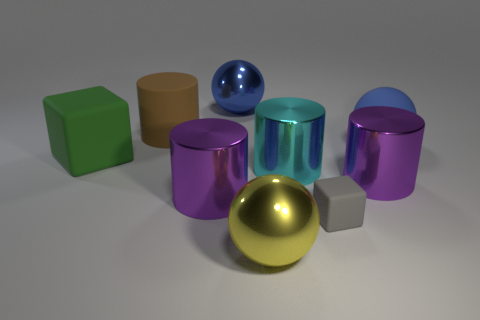Is there anything else that is the same size as the gray block?
Give a very brief answer. No. Is the number of big purple objects greater than the number of small cyan things?
Keep it short and to the point. Yes. How many large balls are behind the gray matte block and left of the cyan cylinder?
Provide a short and direct response. 1. How many shiny spheres are in front of the matte object that is left of the large brown thing?
Provide a short and direct response. 1. Does the metallic object behind the cyan metal thing have the same size as the matte block to the right of the matte cylinder?
Offer a very short reply. No. What number of yellow objects are there?
Give a very brief answer. 1. What number of tiny objects are the same material as the tiny cube?
Offer a very short reply. 0. Is the number of big purple things on the right side of the large yellow shiny thing the same as the number of big yellow spheres?
Provide a short and direct response. Yes. What material is the other ball that is the same color as the big rubber sphere?
Offer a very short reply. Metal. Is the size of the cyan metallic object the same as the matte cube in front of the green block?
Provide a succinct answer. No. 